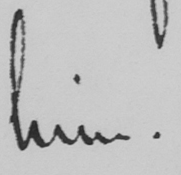Can you tell me what this handwritten text says? him . 